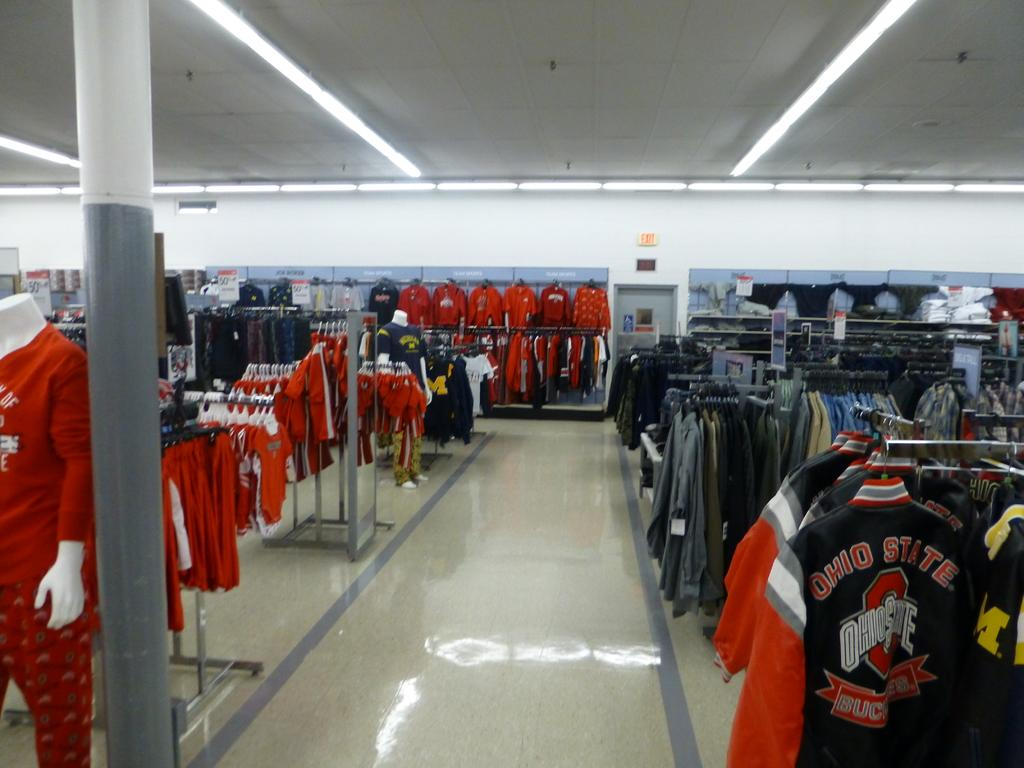<image>
Relay a brief, clear account of the picture shown. Empty store selling clothing including a black jacket which says Ohio State. 